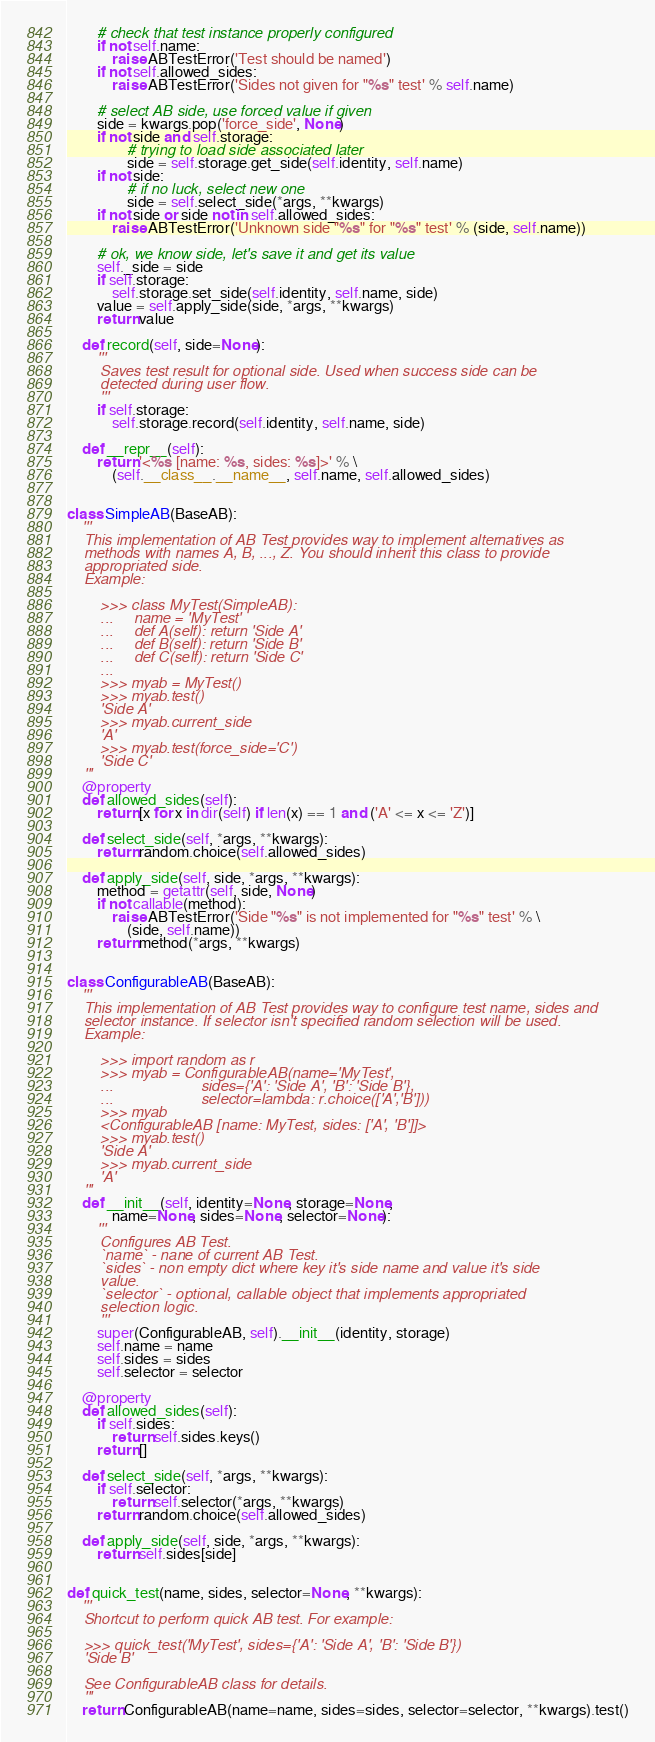Convert code to text. <code><loc_0><loc_0><loc_500><loc_500><_Python_>		# check that test instance properly configured
		if not self.name:
			raise ABTestError('Test should be named')
		if not self.allowed_sides:
			raise ABTestError('Sides not given for "%s" test' % self.name)

		# select AB side, use forced value if given
		side = kwargs.pop('force_side', None)
		if not side and self.storage:
				# trying to load side associated later
				side = self.storage.get_side(self.identity, self.name)
		if not side:
				# if no luck, select new one
				side = self.select_side(*args, **kwargs)
		if not side or side not in self.allowed_sides:
			raise ABTestError('Unknown side "%s" for "%s" test' % (side, self.name))

		# ok, we know side, let's save it and get its value
		self._side = side
		if self.storage:
			self.storage.set_side(self.identity, self.name, side)
		value = self.apply_side(side, *args, **kwargs)
		return value

	def record(self, side=None):
		'''
		Saves test result for optional side. Used when success side can be
		detected during user flow.
		'''
		if self.storage:
			self.storage.record(self.identity, self.name, side)

	def __repr__(self):
		return '<%s [name: %s, sides: %s]>' % \
			(self.__class__.__name__, self.name, self.allowed_sides)


class SimpleAB(BaseAB):
	'''
	This implementation of AB Test provides way to implement alternatives as
	methods with names A, B, ..., Z. You should inherit this class to provide
	appropriated side.
	Example:

		>>> class MyTest(SimpleAB):
		... 	name = 'MyTest'
		...     def A(self): return 'Side A'
		...     def B(self): return 'Side B'
		...     def C(self): return 'Side C'
		...
		>>> myab = MyTest()
		>>> myab.test()
		'Side A'
		>>> myab.current_side
		'A'
		>>> myab.test(force_side='C')
		'Side C'
	'''
	@property
	def allowed_sides(self):
		return [x for x in dir(self) if len(x) == 1 and ('A' <= x <= 'Z')]

	def select_side(self, *args, **kwargs):
		return random.choice(self.allowed_sides)

	def apply_side(self, side, *args, **kwargs):
		method = getattr(self, side, None)
		if not callable(method):
			raise ABTestError('Side "%s" is not implemented for "%s" test' % \
				(side, self.name))
		return method(*args, **kwargs)


class ConfigurableAB(BaseAB):
	'''
	This implementation of AB Test provides way to configure test name, sides and
	selector instance. If selector isn't specified random selection will be used.
	Example:

		>>> import random as r
		>>> myab = ConfigurableAB(name='MyTest',
		... 					sides={'A': 'Side A', 'B': 'Side B'},
		... 					selector=lambda: r.choice(['A','B']))
		>>> myab
		<ConfigurableAB [name: MyTest, sides: ['A', 'B']]>
		>>> myab.test()
		'Side A'
		>>> myab.current_side
		'A'
	'''
	def __init__(self, identity=None, storage=None,
			name=None, sides=None, selector=None):
		'''
		Configures AB Test.
		`name` - nane of current AB Test.
		`sides` - non empty dict where key it's side name and value it's side
		value.
		`selector` - optional, callable object that implements appropriated
		selection logic.
		'''
		super(ConfigurableAB, self).__init__(identity, storage)
		self.name = name
		self.sides = sides
		self.selector = selector

	@property
	def allowed_sides(self):
		if self.sides:
			return self.sides.keys()
		return []

	def select_side(self, *args, **kwargs):
		if self.selector:
			return self.selector(*args, **kwargs)
		return random.choice(self.allowed_sides)

	def apply_side(self, side, *args, **kwargs):
		return self.sides[side]


def quick_test(name, sides, selector=None, **kwargs):
	'''
	Shortcut to perform quick AB test. For example:

	>>> quick_test('MyTest', sides={'A': 'Side A', 'B': 'Side B'})
	'Side B'

	See ConfigurableAB class for details.
	'''
	return ConfigurableAB(name=name, sides=sides, selector=selector, **kwargs).test()
</code> 